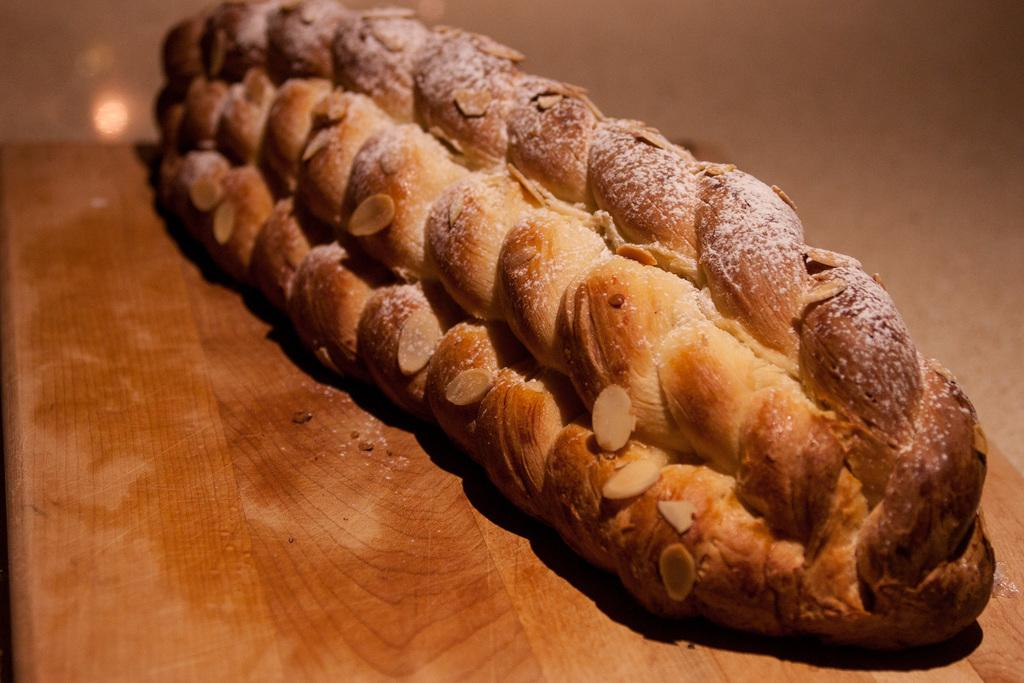What is the main structure visible in the image? There is a wooden platform in the image. What is placed on the wooden platform? There are food items on the wooden platform. What is the purpose of the cheese in the image? There is no cheese mentioned in the image; only food items are mentioned. 